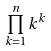Convert formula to latex. <formula><loc_0><loc_0><loc_500><loc_500>\prod _ { k = 1 } ^ { n } k ^ { k }</formula> 